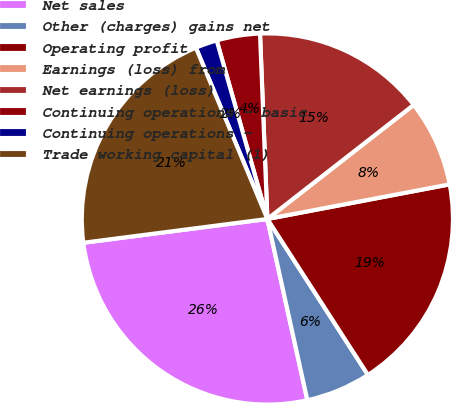<chart> <loc_0><loc_0><loc_500><loc_500><pie_chart><fcel>Net sales<fcel>Other (charges) gains net<fcel>Operating profit<fcel>Earnings (loss) from<fcel>Net earnings (loss)<fcel>Continuing operations - basic<fcel>Continuing operations -<fcel>Trade working capital (1)<nl><fcel>26.41%<fcel>5.66%<fcel>18.87%<fcel>7.55%<fcel>15.09%<fcel>3.77%<fcel>1.89%<fcel>20.75%<nl></chart> 